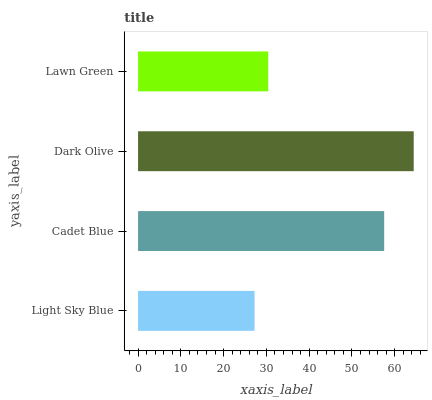Is Light Sky Blue the minimum?
Answer yes or no. Yes. Is Dark Olive the maximum?
Answer yes or no. Yes. Is Cadet Blue the minimum?
Answer yes or no. No. Is Cadet Blue the maximum?
Answer yes or no. No. Is Cadet Blue greater than Light Sky Blue?
Answer yes or no. Yes. Is Light Sky Blue less than Cadet Blue?
Answer yes or no. Yes. Is Light Sky Blue greater than Cadet Blue?
Answer yes or no. No. Is Cadet Blue less than Light Sky Blue?
Answer yes or no. No. Is Cadet Blue the high median?
Answer yes or no. Yes. Is Lawn Green the low median?
Answer yes or no. Yes. Is Dark Olive the high median?
Answer yes or no. No. Is Dark Olive the low median?
Answer yes or no. No. 